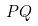<formula> <loc_0><loc_0><loc_500><loc_500>P Q</formula> 